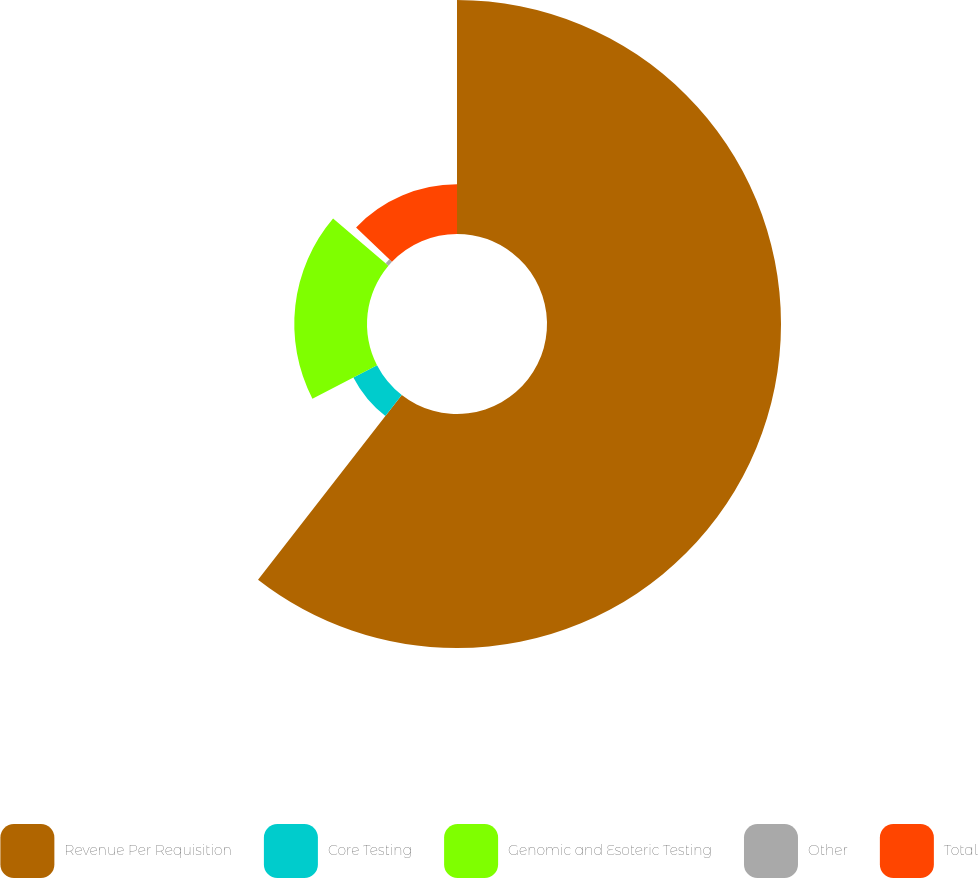Convert chart. <chart><loc_0><loc_0><loc_500><loc_500><pie_chart><fcel>Revenue Per Requisition<fcel>Core Testing<fcel>Genomic and Esoteric Testing<fcel>Other<fcel>Total<nl><fcel>60.53%<fcel>6.89%<fcel>18.81%<fcel>0.93%<fcel>12.85%<nl></chart> 